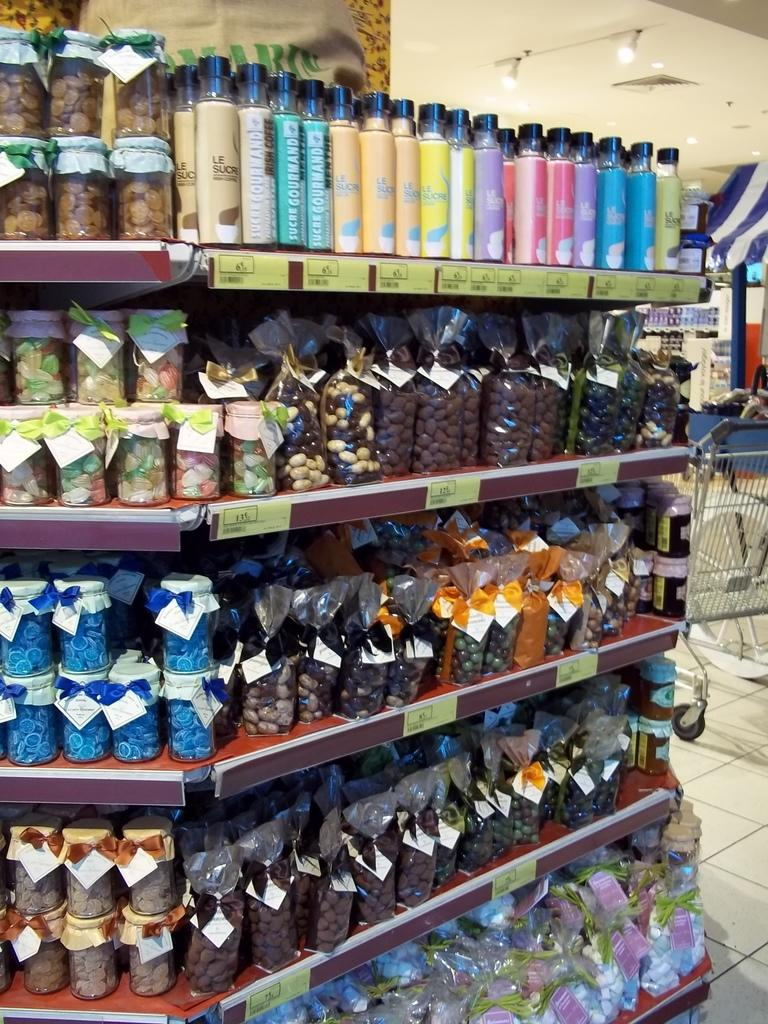What is the main structure visible in the image? There is a rack in the image. What items are placed on the rack? There are packets and bottles on the rack. What type of notebook is visible on the roof in the image? There is no notebook or roof present in the image; it only features a rack with packets and bottles. 